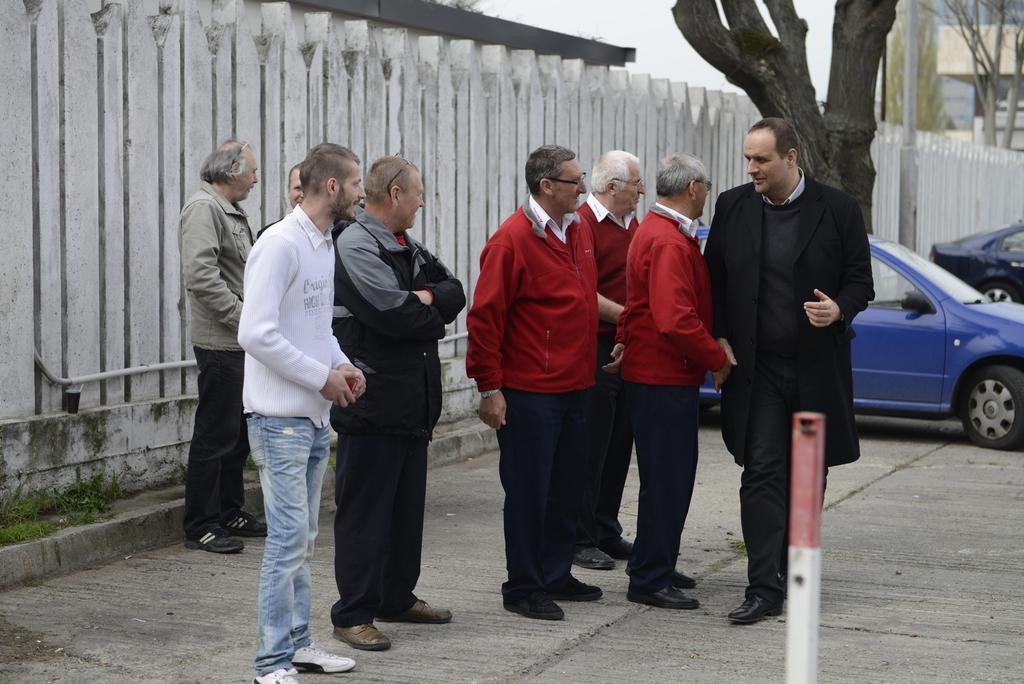How many people are in the image? There is a group of people standing in the image. What can be seen in the foreground of the image? There is a pole in the image. What can be seen in the background of the image? There are cars, a wall, trees, and a pole visible in the background of the image. What is visible in the sky in the image? The sky is visible in the background of the image. Is there any blood visible on the people in the image? There is no blood visible on the people in the image. What type of cover is being used to protect the throat of the person in the image? There is no cover being used to protect the throat of any person in the image. 